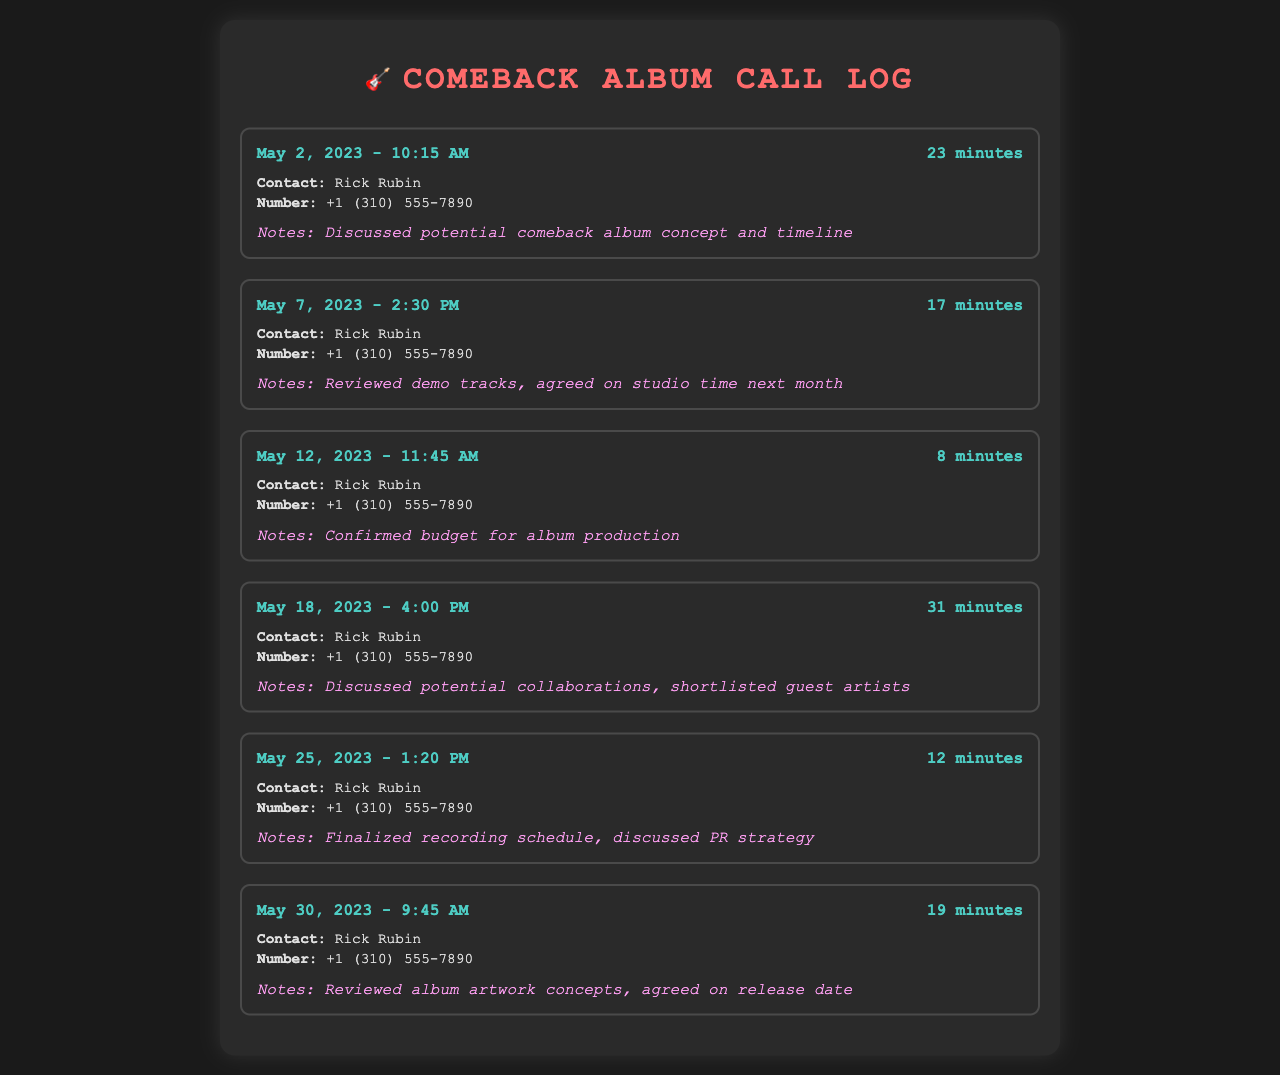What is the name of the contact? The contact listed in the call log is Rick Rubin.
Answer: Rick Rubin What is the number for Rick Rubin? The call log provides the phone number for Rick Rubin, which is +1 (310) 555-7890.
Answer: +1 (310) 555-7890 How many minutes was the longest call? The longest call lasted for 31 minutes, which is noted in the call log on May 18, 2023.
Answer: 31 minutes On what date was the first call made? The first call recorded in the document was made on May 2, 2023.
Answer: May 2, 2023 What was discussed during the call on May 30, 2023? The call on May 30, 2023, included a review of album artwork concepts and an agreement on the release date.
Answer: Reviewed album artwork concepts, agreed on release date How many calls were made in total? The document lists a total of six calls made to Rick Rubin.
Answer: Six calls What was confirmed during the call on May 12, 2023? The call on May 12, 2023, confirmed the budget for album production.
Answer: Confirmed budget for album production What is a topic discussed in the longest call? During the longest call, potential collaborations and shortlisted guest artists were discussed.
Answer: Potential collaborations, shortlisted guest artists What strategy was discussed in the call on May 25, 2023? The call on May 25, 2023, discussed the PR strategy related to the comeback album.
Answer: Discussed PR strategy 